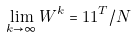Convert formula to latex. <formula><loc_0><loc_0><loc_500><loc_500>\lim _ { k \rightarrow \infty } W ^ { k } = 1 1 ^ { T } / N</formula> 